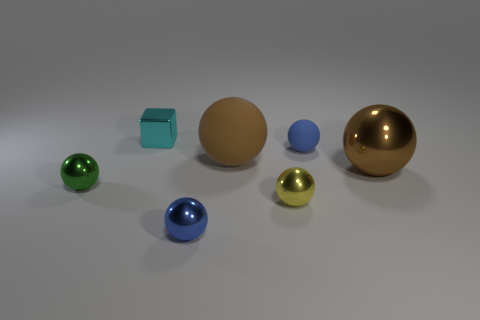Subtract all yellow metallic balls. How many balls are left? 5 Subtract all green balls. How many balls are left? 5 Add 3 small blue rubber spheres. How many objects exist? 10 Subtract 2 balls. How many balls are left? 4 Add 6 big red spheres. How many big red spheres exist? 6 Subtract 0 green cylinders. How many objects are left? 7 Subtract all spheres. How many objects are left? 1 Subtract all brown balls. Subtract all brown cubes. How many balls are left? 4 Subtract all red balls. How many gray cubes are left? 0 Subtract all yellow objects. Subtract all small rubber things. How many objects are left? 5 